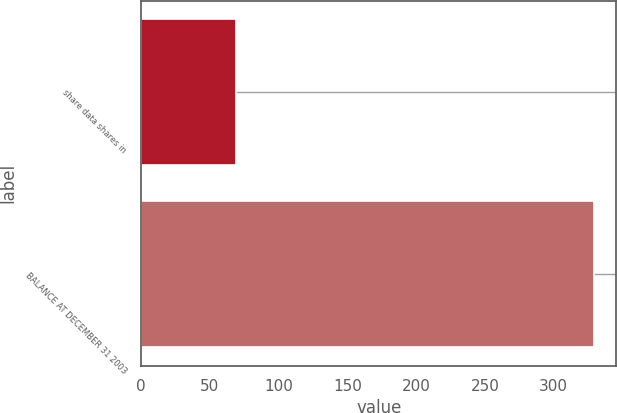Convert chart. <chart><loc_0><loc_0><loc_500><loc_500><bar_chart><fcel>share data shares in<fcel>BALANCE AT DECEMBER 31 2003<nl><fcel>69<fcel>329<nl></chart> 